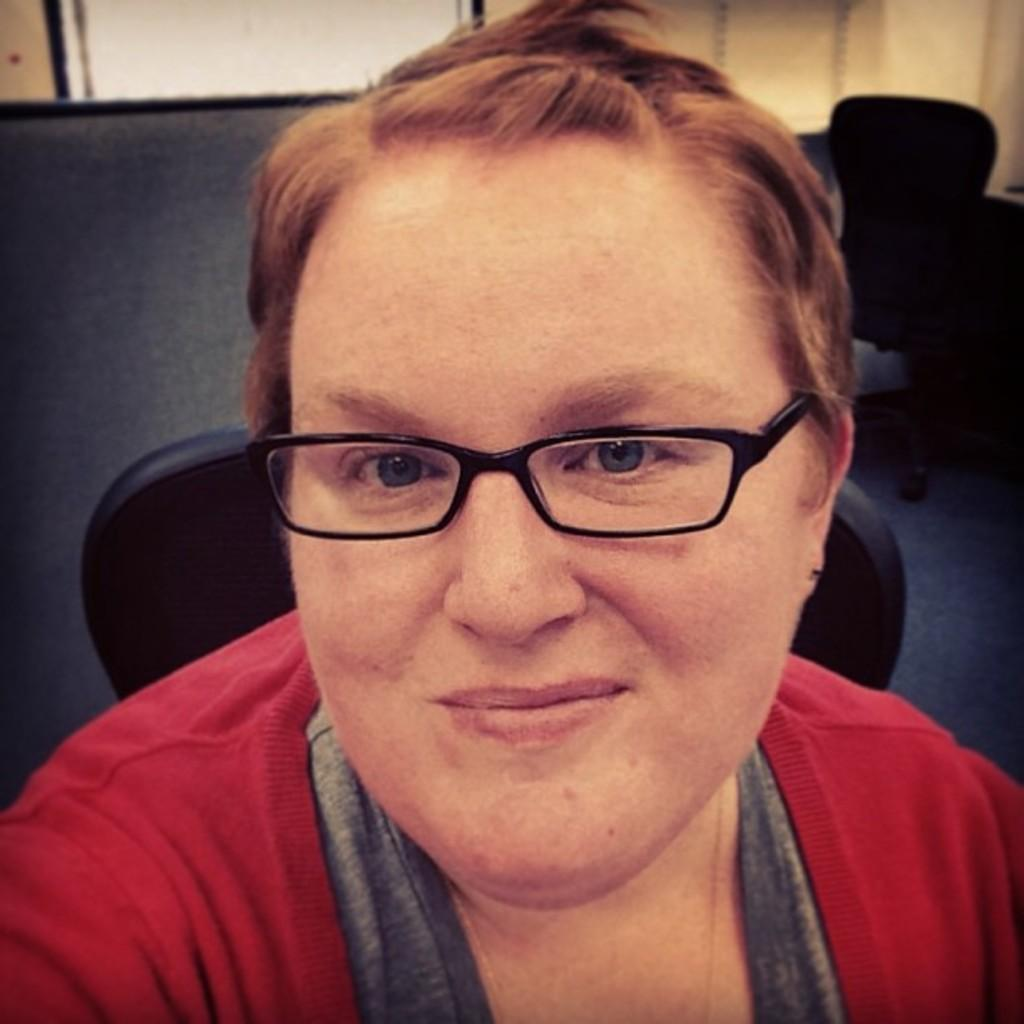What is the lady in the image doing? The lady is sitting on a chair in the image. Can you describe the seating arrangement in the image? There is another chair behind a person in the image. What type of seed is being planted in the image? There is no seed or planting activity depicted in the image. What year is the image taken? The year the image was taken is not mentioned in the provided facts. 